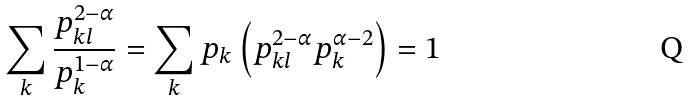Convert formula to latex. <formula><loc_0><loc_0><loc_500><loc_500>\sum _ { k } \frac { p _ { k l } ^ { 2 - \alpha } } { p _ { k } ^ { 1 - \alpha } } = \sum _ { k } p _ { k } \left ( p _ { k l } ^ { 2 - \alpha } p _ { k } ^ { \alpha - 2 } \right ) = 1</formula> 